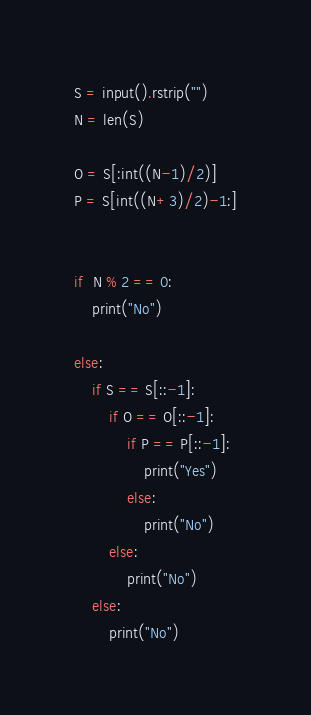<code> <loc_0><loc_0><loc_500><loc_500><_Python_>S = input().rstrip("")
N = len(S)

O = S[:int((N-1)/2)]
P = S[int((N+3)/2)-1:]


if  N % 2 == 0:
    print("No")

else:
    if S == S[::-1]:
        if O == O[::-1]:
            if P == P[::-1]:
                print("Yes")
            else:
                print("No")
        else:
            print("No")
    else:
        print("No")</code> 